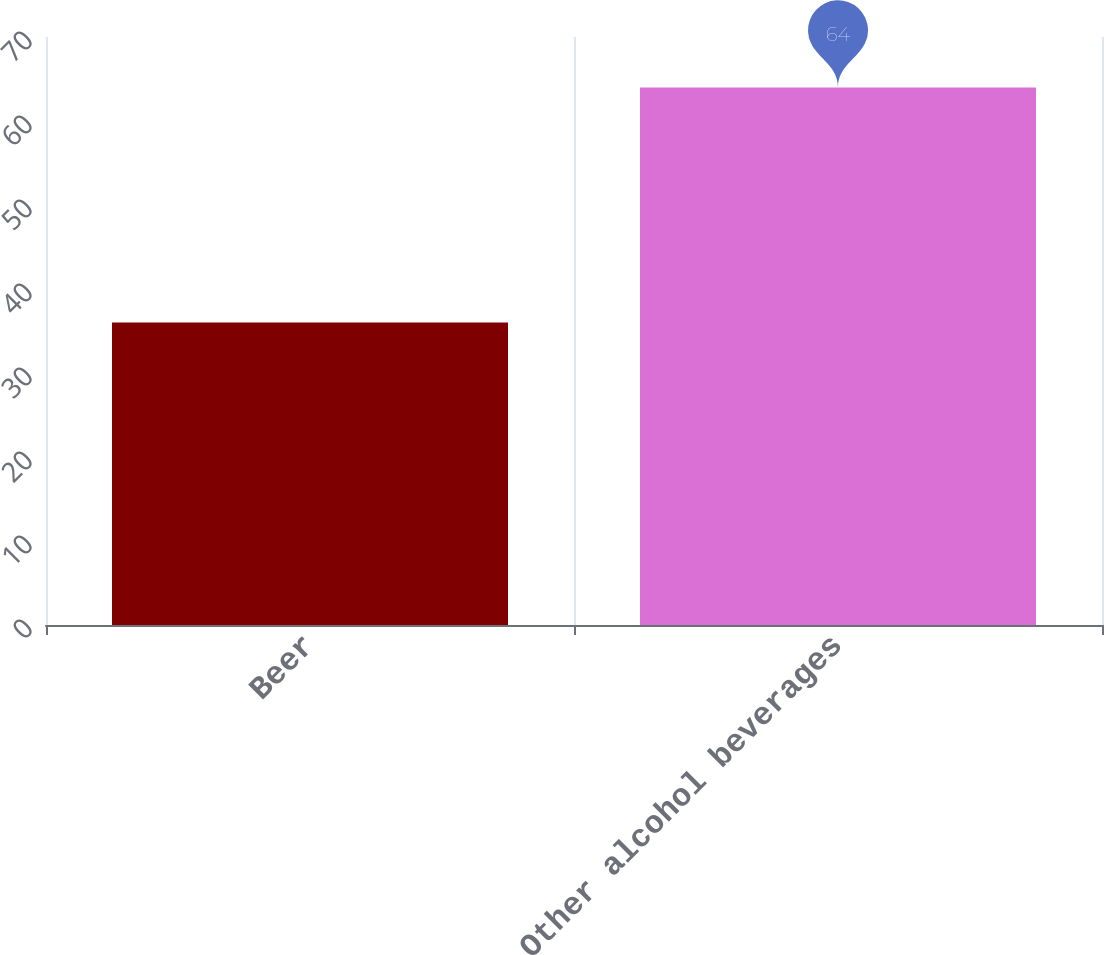Convert chart to OTSL. <chart><loc_0><loc_0><loc_500><loc_500><bar_chart><fcel>Beer<fcel>Other alcohol beverages<nl><fcel>36<fcel>64<nl></chart> 